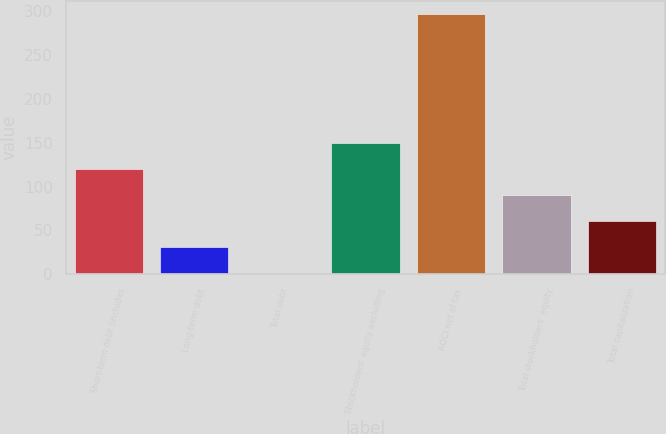Convert chart. <chart><loc_0><loc_0><loc_500><loc_500><bar_chart><fcel>Short-term debt (includes<fcel>Long-term debt<fcel>Total debt<fcel>Stockholders' equity excluding<fcel>AOCI net of tax<fcel>Total stockholders' equity<fcel>Total capitalization<nl><fcel>120<fcel>31.5<fcel>2<fcel>149.5<fcel>297<fcel>90.5<fcel>61<nl></chart> 